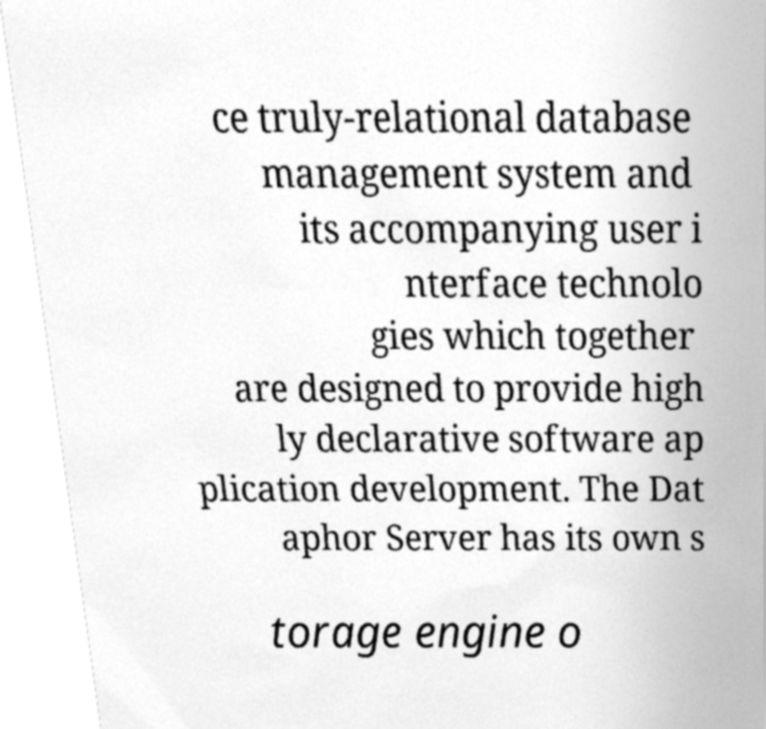Could you assist in decoding the text presented in this image and type it out clearly? ce truly-relational database management system and its accompanying user i nterface technolo gies which together are designed to provide high ly declarative software ap plication development. The Dat aphor Server has its own s torage engine o 